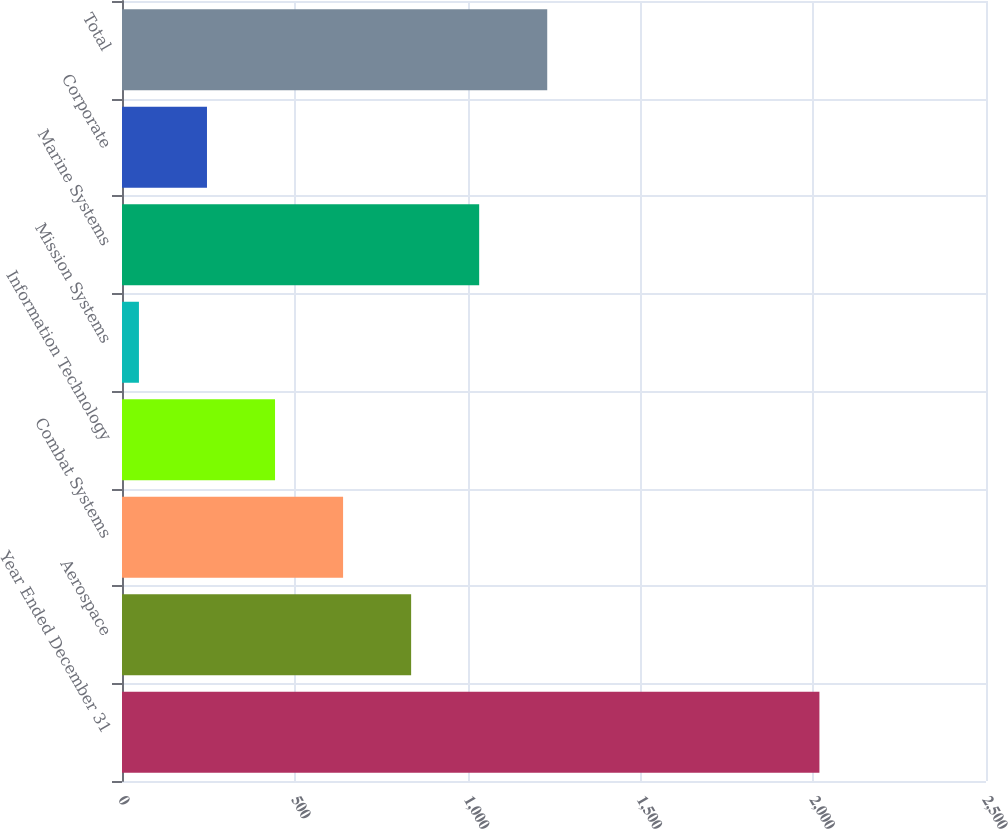Convert chart. <chart><loc_0><loc_0><loc_500><loc_500><bar_chart><fcel>Year Ended December 31<fcel>Aerospace<fcel>Combat Systems<fcel>Information Technology<fcel>Mission Systems<fcel>Marine Systems<fcel>Corporate<fcel>Total<nl><fcel>2018<fcel>836.6<fcel>639.7<fcel>442.8<fcel>49<fcel>1033.5<fcel>245.9<fcel>1230.4<nl></chart> 